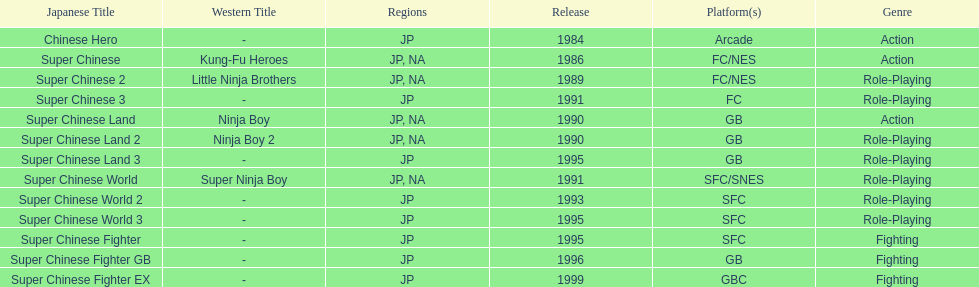Would you be able to parse every entry in this table? {'header': ['Japanese Title', 'Western Title', 'Regions', 'Release', 'Platform(s)', 'Genre'], 'rows': [['Chinese Hero', '-', 'JP', '1984', 'Arcade', 'Action'], ['Super Chinese', 'Kung-Fu Heroes', 'JP, NA', '1986', 'FC/NES', 'Action'], ['Super Chinese 2', 'Little Ninja Brothers', 'JP, NA', '1989', 'FC/NES', 'Role-Playing'], ['Super Chinese 3', '-', 'JP', '1991', 'FC', 'Role-Playing'], ['Super Chinese Land', 'Ninja Boy', 'JP, NA', '1990', 'GB', 'Action'], ['Super Chinese Land 2', 'Ninja Boy 2', 'JP, NA', '1990', 'GB', 'Role-Playing'], ['Super Chinese Land 3', '-', 'JP', '1995', 'GB', 'Role-Playing'], ['Super Chinese World', 'Super Ninja Boy', 'JP, NA', '1991', 'SFC/SNES', 'Role-Playing'], ['Super Chinese World 2', '-', 'JP', '1993', 'SFC', 'Role-Playing'], ['Super Chinese World 3', '-', 'JP', '1995', 'SFC', 'Role-Playing'], ['Super Chinese Fighter', '-', 'JP', '1995', 'SFC', 'Fighting'], ['Super Chinese Fighter GB', '-', 'JP', '1996', 'GB', 'Fighting'], ['Super Chinese Fighter EX', '-', 'JP', '1999', 'GBC', 'Fighting']]} What is the overall count of super chinese games released? 13. 